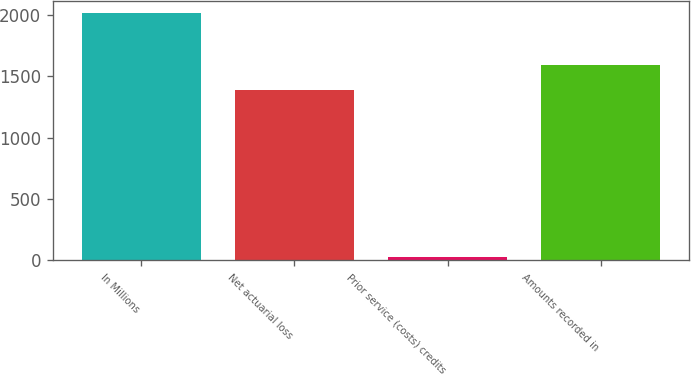Convert chart. <chart><loc_0><loc_0><loc_500><loc_500><bar_chart><fcel>In Millions<fcel>Net actuarial loss<fcel>Prior service (costs) credits<fcel>Amounts recorded in<nl><fcel>2014<fcel>1389.2<fcel>26.1<fcel>1587.99<nl></chart> 